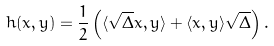<formula> <loc_0><loc_0><loc_500><loc_500>h ( x , y ) = \frac { 1 } { 2 } \left ( \langle \sqrt { \Delta } x , y \rangle + \langle x , y \rangle \sqrt { \Delta } \right ) .</formula> 